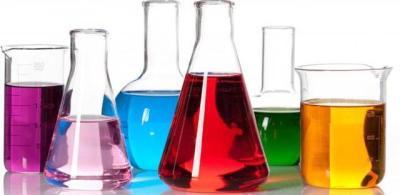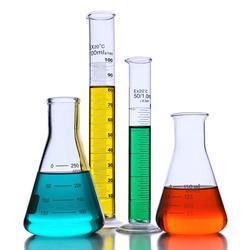The first image is the image on the left, the second image is the image on the right. Given the left and right images, does the statement "There are exactly three object in one of the images." hold true? Answer yes or no. No. The first image is the image on the left, the second image is the image on the right. Considering the images on both sides, is "The containers in the image on the left are set up near a blue light." valid? Answer yes or no. No. 